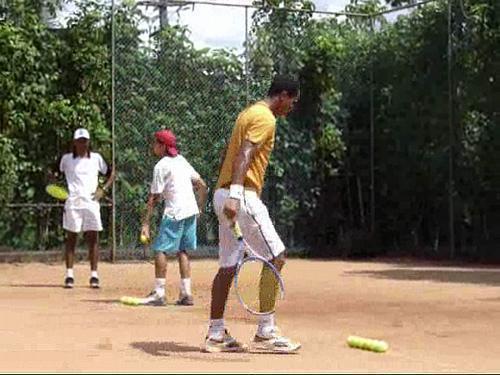How many people can be seen?
Give a very brief answer. 3. 